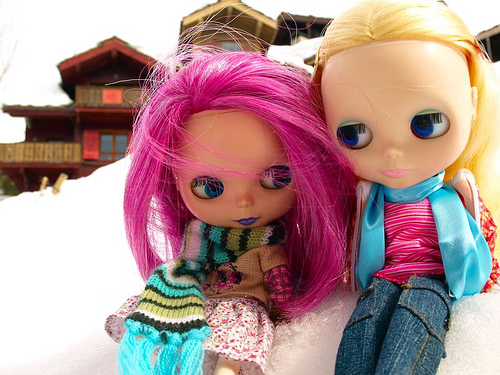<image>
Is the hat behind the jeans? No. The hat is not behind the jeans. From this viewpoint, the hat appears to be positioned elsewhere in the scene. Where is the toy in relation to the house? Is it to the left of the house? No. The toy is not to the left of the house. From this viewpoint, they have a different horizontal relationship. 